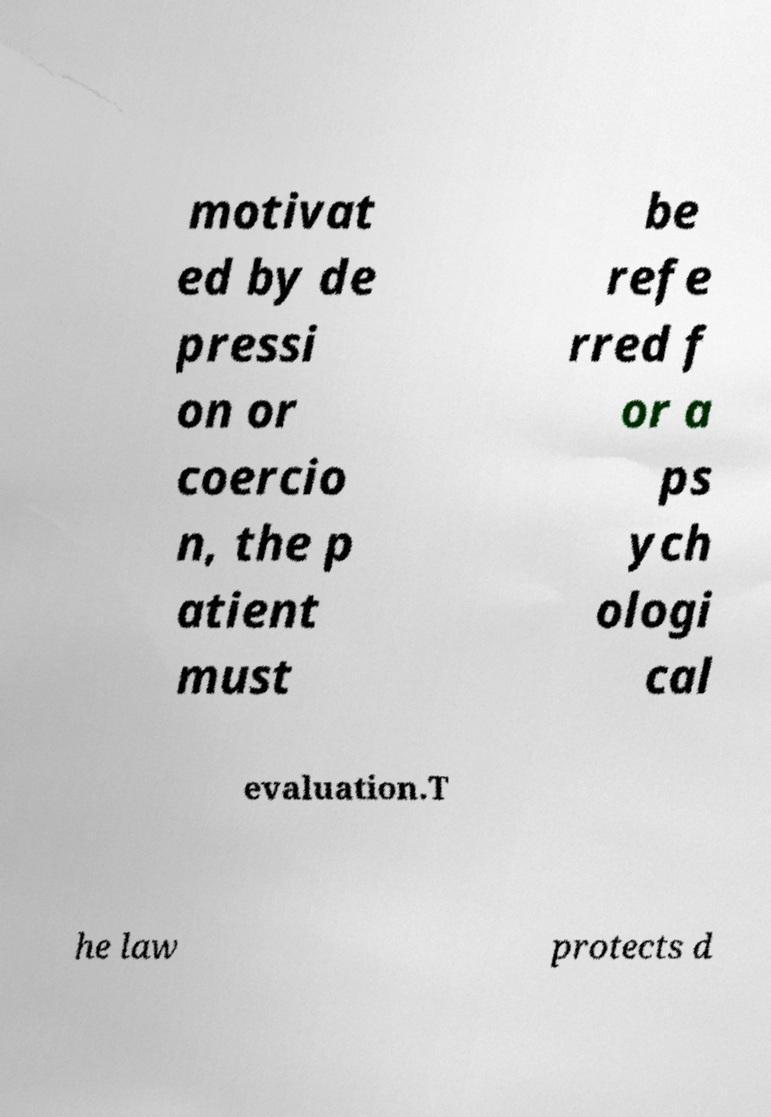Can you accurately transcribe the text from the provided image for me? motivat ed by de pressi on or coercio n, the p atient must be refe rred f or a ps ych ologi cal evaluation.T he law protects d 